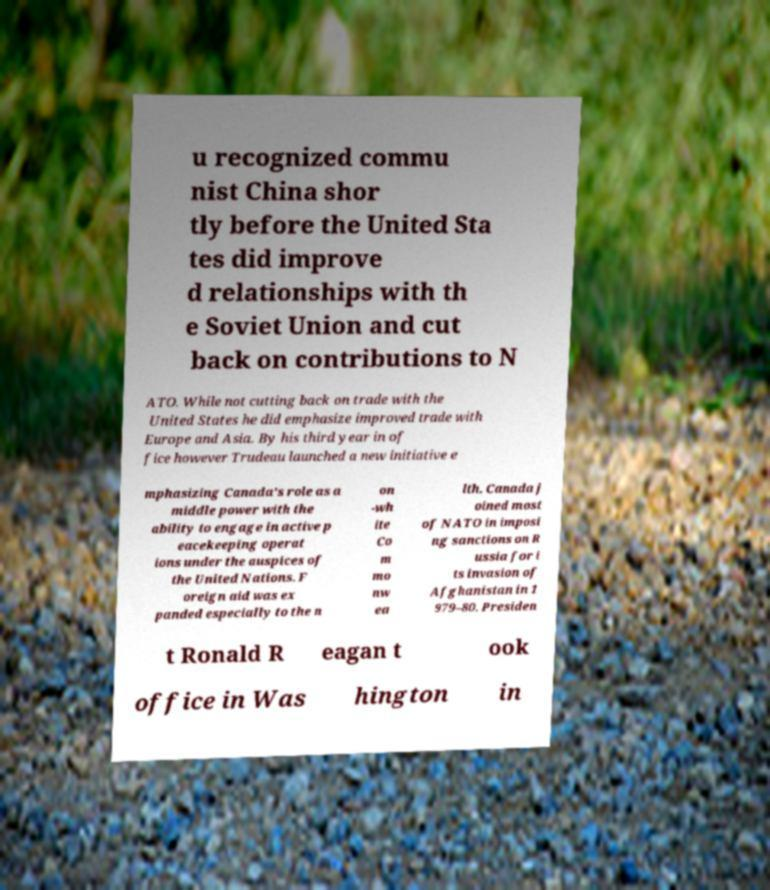Could you assist in decoding the text presented in this image and type it out clearly? u recognized commu nist China shor tly before the United Sta tes did improve d relationships with th e Soviet Union and cut back on contributions to N ATO. While not cutting back on trade with the United States he did emphasize improved trade with Europe and Asia. By his third year in of fice however Trudeau launched a new initiative e mphasizing Canada's role as a middle power with the ability to engage in active p eacekeeping operat ions under the auspices of the United Nations. F oreign aid was ex panded especially to the n on -wh ite Co m mo nw ea lth. Canada j oined most of NATO in imposi ng sanctions on R ussia for i ts invasion of Afghanistan in 1 979–80. Presiden t Ronald R eagan t ook office in Was hington in 